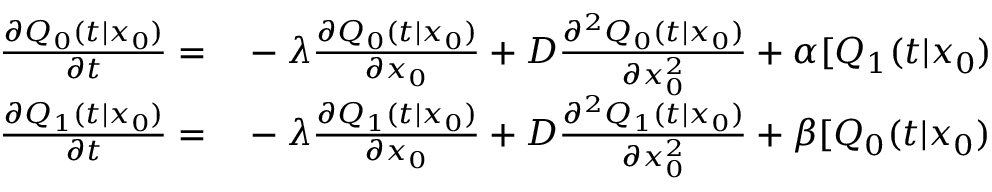<formula> <loc_0><loc_0><loc_500><loc_500>\begin{array} { r l } { \frac { \partial Q _ { 0 } ( t | x _ { 0 } ) } { \partial t } = } & - \lambda \frac { \partial Q _ { 0 } ( t | x _ { 0 } ) } { \partial x _ { 0 } } + D \frac { \partial ^ { 2 } Q _ { 0 } ( t | x _ { 0 } ) } { \partial x _ { 0 } ^ { 2 } } + \alpha [ Q _ { 1 } ( t | x _ { 0 } ) } \\ { \frac { \partial Q _ { 1 } ( t | x _ { 0 } ) } { \partial t } = } & - \lambda \frac { \partial Q _ { 1 } ( t | x _ { 0 } ) } { \partial x _ { 0 } } + D \frac { \partial ^ { 2 } Q _ { 1 } ( t | x _ { 0 } ) } { \partial x _ { 0 } ^ { 2 } } + \beta [ Q _ { 0 } ( t | x _ { 0 } ) } \end{array}</formula> 